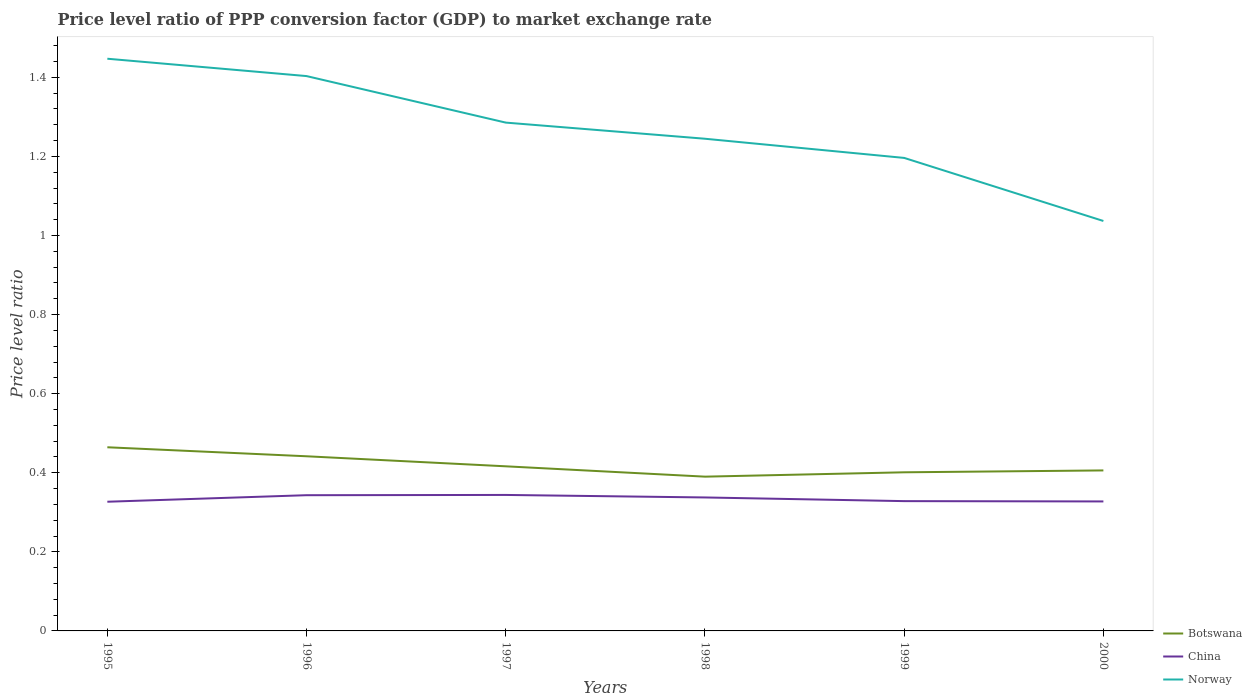How many different coloured lines are there?
Keep it short and to the point. 3. Is the number of lines equal to the number of legend labels?
Provide a succinct answer. Yes. Across all years, what is the maximum price level ratio in China?
Keep it short and to the point. 0.33. What is the total price level ratio in China in the graph?
Provide a short and direct response. 0.01. What is the difference between the highest and the second highest price level ratio in China?
Provide a short and direct response. 0.02. Is the price level ratio in Botswana strictly greater than the price level ratio in China over the years?
Make the answer very short. No. What is the difference between two consecutive major ticks on the Y-axis?
Provide a succinct answer. 0.2. Are the values on the major ticks of Y-axis written in scientific E-notation?
Ensure brevity in your answer.  No. Does the graph contain any zero values?
Your response must be concise. No. Where does the legend appear in the graph?
Offer a very short reply. Bottom right. How are the legend labels stacked?
Your answer should be compact. Vertical. What is the title of the graph?
Offer a very short reply. Price level ratio of PPP conversion factor (GDP) to market exchange rate. What is the label or title of the Y-axis?
Make the answer very short. Price level ratio. What is the Price level ratio of Botswana in 1995?
Offer a very short reply. 0.46. What is the Price level ratio in China in 1995?
Make the answer very short. 0.33. What is the Price level ratio of Norway in 1995?
Provide a succinct answer. 1.45. What is the Price level ratio of Botswana in 1996?
Your response must be concise. 0.44. What is the Price level ratio in China in 1996?
Give a very brief answer. 0.34. What is the Price level ratio in Norway in 1996?
Give a very brief answer. 1.4. What is the Price level ratio of Botswana in 1997?
Provide a short and direct response. 0.42. What is the Price level ratio of China in 1997?
Ensure brevity in your answer.  0.34. What is the Price level ratio of Norway in 1997?
Keep it short and to the point. 1.29. What is the Price level ratio in Botswana in 1998?
Your response must be concise. 0.39. What is the Price level ratio of China in 1998?
Make the answer very short. 0.34. What is the Price level ratio of Norway in 1998?
Your answer should be compact. 1.24. What is the Price level ratio in Botswana in 1999?
Your response must be concise. 0.4. What is the Price level ratio of China in 1999?
Give a very brief answer. 0.33. What is the Price level ratio of Norway in 1999?
Make the answer very short. 1.2. What is the Price level ratio in Botswana in 2000?
Ensure brevity in your answer.  0.41. What is the Price level ratio of China in 2000?
Make the answer very short. 0.33. What is the Price level ratio in Norway in 2000?
Offer a terse response. 1.04. Across all years, what is the maximum Price level ratio of Botswana?
Offer a very short reply. 0.46. Across all years, what is the maximum Price level ratio of China?
Offer a very short reply. 0.34. Across all years, what is the maximum Price level ratio of Norway?
Offer a terse response. 1.45. Across all years, what is the minimum Price level ratio of Botswana?
Provide a short and direct response. 0.39. Across all years, what is the minimum Price level ratio of China?
Provide a succinct answer. 0.33. Across all years, what is the minimum Price level ratio of Norway?
Your response must be concise. 1.04. What is the total Price level ratio of Botswana in the graph?
Keep it short and to the point. 2.52. What is the total Price level ratio of China in the graph?
Make the answer very short. 2.01. What is the total Price level ratio in Norway in the graph?
Ensure brevity in your answer.  7.61. What is the difference between the Price level ratio of Botswana in 1995 and that in 1996?
Offer a terse response. 0.02. What is the difference between the Price level ratio of China in 1995 and that in 1996?
Make the answer very short. -0.02. What is the difference between the Price level ratio of Norway in 1995 and that in 1996?
Provide a short and direct response. 0.04. What is the difference between the Price level ratio in Botswana in 1995 and that in 1997?
Make the answer very short. 0.05. What is the difference between the Price level ratio of China in 1995 and that in 1997?
Offer a terse response. -0.02. What is the difference between the Price level ratio of Norway in 1995 and that in 1997?
Your response must be concise. 0.16. What is the difference between the Price level ratio of Botswana in 1995 and that in 1998?
Give a very brief answer. 0.07. What is the difference between the Price level ratio of China in 1995 and that in 1998?
Your answer should be compact. -0.01. What is the difference between the Price level ratio of Norway in 1995 and that in 1998?
Keep it short and to the point. 0.2. What is the difference between the Price level ratio in Botswana in 1995 and that in 1999?
Provide a short and direct response. 0.06. What is the difference between the Price level ratio of China in 1995 and that in 1999?
Keep it short and to the point. -0. What is the difference between the Price level ratio of Norway in 1995 and that in 1999?
Your answer should be very brief. 0.25. What is the difference between the Price level ratio in Botswana in 1995 and that in 2000?
Give a very brief answer. 0.06. What is the difference between the Price level ratio in China in 1995 and that in 2000?
Ensure brevity in your answer.  -0. What is the difference between the Price level ratio in Norway in 1995 and that in 2000?
Ensure brevity in your answer.  0.41. What is the difference between the Price level ratio of Botswana in 1996 and that in 1997?
Ensure brevity in your answer.  0.03. What is the difference between the Price level ratio in China in 1996 and that in 1997?
Make the answer very short. -0. What is the difference between the Price level ratio in Norway in 1996 and that in 1997?
Your response must be concise. 0.12. What is the difference between the Price level ratio in Botswana in 1996 and that in 1998?
Ensure brevity in your answer.  0.05. What is the difference between the Price level ratio in China in 1996 and that in 1998?
Offer a very short reply. 0.01. What is the difference between the Price level ratio of Norway in 1996 and that in 1998?
Offer a terse response. 0.16. What is the difference between the Price level ratio in Botswana in 1996 and that in 1999?
Offer a terse response. 0.04. What is the difference between the Price level ratio in China in 1996 and that in 1999?
Provide a succinct answer. 0.01. What is the difference between the Price level ratio in Norway in 1996 and that in 1999?
Make the answer very short. 0.21. What is the difference between the Price level ratio in Botswana in 1996 and that in 2000?
Ensure brevity in your answer.  0.04. What is the difference between the Price level ratio in China in 1996 and that in 2000?
Offer a terse response. 0.02. What is the difference between the Price level ratio in Norway in 1996 and that in 2000?
Keep it short and to the point. 0.37. What is the difference between the Price level ratio in Botswana in 1997 and that in 1998?
Give a very brief answer. 0.03. What is the difference between the Price level ratio in China in 1997 and that in 1998?
Your answer should be compact. 0.01. What is the difference between the Price level ratio in Norway in 1997 and that in 1998?
Provide a succinct answer. 0.04. What is the difference between the Price level ratio in Botswana in 1997 and that in 1999?
Your answer should be very brief. 0.02. What is the difference between the Price level ratio of China in 1997 and that in 1999?
Your answer should be very brief. 0.02. What is the difference between the Price level ratio in Norway in 1997 and that in 1999?
Your answer should be compact. 0.09. What is the difference between the Price level ratio in Botswana in 1997 and that in 2000?
Your answer should be very brief. 0.01. What is the difference between the Price level ratio of China in 1997 and that in 2000?
Your answer should be compact. 0.02. What is the difference between the Price level ratio of Norway in 1997 and that in 2000?
Ensure brevity in your answer.  0.25. What is the difference between the Price level ratio in Botswana in 1998 and that in 1999?
Your answer should be very brief. -0.01. What is the difference between the Price level ratio of China in 1998 and that in 1999?
Your response must be concise. 0.01. What is the difference between the Price level ratio of Norway in 1998 and that in 1999?
Offer a very short reply. 0.05. What is the difference between the Price level ratio in Botswana in 1998 and that in 2000?
Make the answer very short. -0.02. What is the difference between the Price level ratio of China in 1998 and that in 2000?
Keep it short and to the point. 0.01. What is the difference between the Price level ratio in Norway in 1998 and that in 2000?
Make the answer very short. 0.21. What is the difference between the Price level ratio in Botswana in 1999 and that in 2000?
Your answer should be compact. -0. What is the difference between the Price level ratio in China in 1999 and that in 2000?
Your answer should be compact. 0. What is the difference between the Price level ratio in Norway in 1999 and that in 2000?
Ensure brevity in your answer.  0.16. What is the difference between the Price level ratio of Botswana in 1995 and the Price level ratio of China in 1996?
Your answer should be very brief. 0.12. What is the difference between the Price level ratio of Botswana in 1995 and the Price level ratio of Norway in 1996?
Your response must be concise. -0.94. What is the difference between the Price level ratio in China in 1995 and the Price level ratio in Norway in 1996?
Your answer should be very brief. -1.08. What is the difference between the Price level ratio of Botswana in 1995 and the Price level ratio of China in 1997?
Keep it short and to the point. 0.12. What is the difference between the Price level ratio of Botswana in 1995 and the Price level ratio of Norway in 1997?
Offer a terse response. -0.82. What is the difference between the Price level ratio in China in 1995 and the Price level ratio in Norway in 1997?
Provide a short and direct response. -0.96. What is the difference between the Price level ratio of Botswana in 1995 and the Price level ratio of China in 1998?
Give a very brief answer. 0.13. What is the difference between the Price level ratio in Botswana in 1995 and the Price level ratio in Norway in 1998?
Your answer should be compact. -0.78. What is the difference between the Price level ratio of China in 1995 and the Price level ratio of Norway in 1998?
Give a very brief answer. -0.92. What is the difference between the Price level ratio in Botswana in 1995 and the Price level ratio in China in 1999?
Make the answer very short. 0.14. What is the difference between the Price level ratio of Botswana in 1995 and the Price level ratio of Norway in 1999?
Provide a short and direct response. -0.73. What is the difference between the Price level ratio of China in 1995 and the Price level ratio of Norway in 1999?
Your answer should be very brief. -0.87. What is the difference between the Price level ratio in Botswana in 1995 and the Price level ratio in China in 2000?
Your response must be concise. 0.14. What is the difference between the Price level ratio in Botswana in 1995 and the Price level ratio in Norway in 2000?
Keep it short and to the point. -0.57. What is the difference between the Price level ratio of China in 1995 and the Price level ratio of Norway in 2000?
Offer a very short reply. -0.71. What is the difference between the Price level ratio of Botswana in 1996 and the Price level ratio of China in 1997?
Your response must be concise. 0.1. What is the difference between the Price level ratio of Botswana in 1996 and the Price level ratio of Norway in 1997?
Your answer should be compact. -0.84. What is the difference between the Price level ratio of China in 1996 and the Price level ratio of Norway in 1997?
Give a very brief answer. -0.94. What is the difference between the Price level ratio of Botswana in 1996 and the Price level ratio of China in 1998?
Your response must be concise. 0.1. What is the difference between the Price level ratio of Botswana in 1996 and the Price level ratio of Norway in 1998?
Provide a short and direct response. -0.8. What is the difference between the Price level ratio in China in 1996 and the Price level ratio in Norway in 1998?
Provide a short and direct response. -0.9. What is the difference between the Price level ratio in Botswana in 1996 and the Price level ratio in China in 1999?
Give a very brief answer. 0.11. What is the difference between the Price level ratio in Botswana in 1996 and the Price level ratio in Norway in 1999?
Keep it short and to the point. -0.75. What is the difference between the Price level ratio of China in 1996 and the Price level ratio of Norway in 1999?
Your answer should be very brief. -0.85. What is the difference between the Price level ratio of Botswana in 1996 and the Price level ratio of China in 2000?
Your response must be concise. 0.11. What is the difference between the Price level ratio of Botswana in 1996 and the Price level ratio of Norway in 2000?
Your answer should be compact. -0.59. What is the difference between the Price level ratio in China in 1996 and the Price level ratio in Norway in 2000?
Your answer should be very brief. -0.69. What is the difference between the Price level ratio of Botswana in 1997 and the Price level ratio of China in 1998?
Offer a very short reply. 0.08. What is the difference between the Price level ratio in Botswana in 1997 and the Price level ratio in Norway in 1998?
Offer a terse response. -0.83. What is the difference between the Price level ratio in China in 1997 and the Price level ratio in Norway in 1998?
Your response must be concise. -0.9. What is the difference between the Price level ratio of Botswana in 1997 and the Price level ratio of China in 1999?
Your answer should be very brief. 0.09. What is the difference between the Price level ratio in Botswana in 1997 and the Price level ratio in Norway in 1999?
Give a very brief answer. -0.78. What is the difference between the Price level ratio in China in 1997 and the Price level ratio in Norway in 1999?
Keep it short and to the point. -0.85. What is the difference between the Price level ratio of Botswana in 1997 and the Price level ratio of China in 2000?
Provide a short and direct response. 0.09. What is the difference between the Price level ratio in Botswana in 1997 and the Price level ratio in Norway in 2000?
Your answer should be very brief. -0.62. What is the difference between the Price level ratio in China in 1997 and the Price level ratio in Norway in 2000?
Your answer should be compact. -0.69. What is the difference between the Price level ratio in Botswana in 1998 and the Price level ratio in China in 1999?
Your answer should be very brief. 0.06. What is the difference between the Price level ratio of Botswana in 1998 and the Price level ratio of Norway in 1999?
Give a very brief answer. -0.81. What is the difference between the Price level ratio of China in 1998 and the Price level ratio of Norway in 1999?
Your answer should be very brief. -0.86. What is the difference between the Price level ratio of Botswana in 1998 and the Price level ratio of China in 2000?
Give a very brief answer. 0.06. What is the difference between the Price level ratio of Botswana in 1998 and the Price level ratio of Norway in 2000?
Offer a terse response. -0.65. What is the difference between the Price level ratio of China in 1998 and the Price level ratio of Norway in 2000?
Provide a short and direct response. -0.7. What is the difference between the Price level ratio in Botswana in 1999 and the Price level ratio in China in 2000?
Provide a short and direct response. 0.07. What is the difference between the Price level ratio of Botswana in 1999 and the Price level ratio of Norway in 2000?
Keep it short and to the point. -0.64. What is the difference between the Price level ratio of China in 1999 and the Price level ratio of Norway in 2000?
Make the answer very short. -0.71. What is the average Price level ratio of Botswana per year?
Make the answer very short. 0.42. What is the average Price level ratio in China per year?
Your response must be concise. 0.33. What is the average Price level ratio in Norway per year?
Offer a very short reply. 1.27. In the year 1995, what is the difference between the Price level ratio of Botswana and Price level ratio of China?
Offer a terse response. 0.14. In the year 1995, what is the difference between the Price level ratio of Botswana and Price level ratio of Norway?
Offer a very short reply. -0.98. In the year 1995, what is the difference between the Price level ratio of China and Price level ratio of Norway?
Offer a very short reply. -1.12. In the year 1996, what is the difference between the Price level ratio in Botswana and Price level ratio in China?
Keep it short and to the point. 0.1. In the year 1996, what is the difference between the Price level ratio of Botswana and Price level ratio of Norway?
Your answer should be compact. -0.96. In the year 1996, what is the difference between the Price level ratio of China and Price level ratio of Norway?
Keep it short and to the point. -1.06. In the year 1997, what is the difference between the Price level ratio of Botswana and Price level ratio of China?
Ensure brevity in your answer.  0.07. In the year 1997, what is the difference between the Price level ratio in Botswana and Price level ratio in Norway?
Make the answer very short. -0.87. In the year 1997, what is the difference between the Price level ratio of China and Price level ratio of Norway?
Make the answer very short. -0.94. In the year 1998, what is the difference between the Price level ratio of Botswana and Price level ratio of China?
Your answer should be compact. 0.05. In the year 1998, what is the difference between the Price level ratio in Botswana and Price level ratio in Norway?
Ensure brevity in your answer.  -0.85. In the year 1998, what is the difference between the Price level ratio in China and Price level ratio in Norway?
Your answer should be very brief. -0.91. In the year 1999, what is the difference between the Price level ratio in Botswana and Price level ratio in China?
Your answer should be compact. 0.07. In the year 1999, what is the difference between the Price level ratio in Botswana and Price level ratio in Norway?
Keep it short and to the point. -0.8. In the year 1999, what is the difference between the Price level ratio of China and Price level ratio of Norway?
Ensure brevity in your answer.  -0.87. In the year 2000, what is the difference between the Price level ratio of Botswana and Price level ratio of China?
Provide a succinct answer. 0.08. In the year 2000, what is the difference between the Price level ratio in Botswana and Price level ratio in Norway?
Give a very brief answer. -0.63. In the year 2000, what is the difference between the Price level ratio of China and Price level ratio of Norway?
Offer a very short reply. -0.71. What is the ratio of the Price level ratio in Botswana in 1995 to that in 1996?
Your answer should be very brief. 1.05. What is the ratio of the Price level ratio in China in 1995 to that in 1996?
Ensure brevity in your answer.  0.95. What is the ratio of the Price level ratio of Norway in 1995 to that in 1996?
Offer a very short reply. 1.03. What is the ratio of the Price level ratio of Botswana in 1995 to that in 1997?
Give a very brief answer. 1.12. What is the ratio of the Price level ratio of China in 1995 to that in 1997?
Your answer should be very brief. 0.95. What is the ratio of the Price level ratio of Norway in 1995 to that in 1997?
Your response must be concise. 1.13. What is the ratio of the Price level ratio in Botswana in 1995 to that in 1998?
Your answer should be very brief. 1.19. What is the ratio of the Price level ratio in China in 1995 to that in 1998?
Your answer should be very brief. 0.97. What is the ratio of the Price level ratio of Norway in 1995 to that in 1998?
Offer a terse response. 1.16. What is the ratio of the Price level ratio of Botswana in 1995 to that in 1999?
Offer a very short reply. 1.16. What is the ratio of the Price level ratio in China in 1995 to that in 1999?
Provide a short and direct response. 1. What is the ratio of the Price level ratio of Norway in 1995 to that in 1999?
Give a very brief answer. 1.21. What is the ratio of the Price level ratio in Botswana in 1995 to that in 2000?
Your response must be concise. 1.14. What is the ratio of the Price level ratio in China in 1995 to that in 2000?
Provide a succinct answer. 1. What is the ratio of the Price level ratio of Norway in 1995 to that in 2000?
Provide a short and direct response. 1.4. What is the ratio of the Price level ratio of Botswana in 1996 to that in 1997?
Give a very brief answer. 1.06. What is the ratio of the Price level ratio of Norway in 1996 to that in 1997?
Give a very brief answer. 1.09. What is the ratio of the Price level ratio of Botswana in 1996 to that in 1998?
Your response must be concise. 1.13. What is the ratio of the Price level ratio of China in 1996 to that in 1998?
Offer a terse response. 1.02. What is the ratio of the Price level ratio in Norway in 1996 to that in 1998?
Provide a succinct answer. 1.13. What is the ratio of the Price level ratio of Botswana in 1996 to that in 1999?
Your answer should be very brief. 1.1. What is the ratio of the Price level ratio in China in 1996 to that in 1999?
Offer a very short reply. 1.05. What is the ratio of the Price level ratio of Norway in 1996 to that in 1999?
Ensure brevity in your answer.  1.17. What is the ratio of the Price level ratio of Botswana in 1996 to that in 2000?
Your response must be concise. 1.09. What is the ratio of the Price level ratio of China in 1996 to that in 2000?
Keep it short and to the point. 1.05. What is the ratio of the Price level ratio in Norway in 1996 to that in 2000?
Your response must be concise. 1.35. What is the ratio of the Price level ratio of Botswana in 1997 to that in 1998?
Your answer should be compact. 1.07. What is the ratio of the Price level ratio of China in 1997 to that in 1998?
Your answer should be compact. 1.02. What is the ratio of the Price level ratio in Norway in 1997 to that in 1998?
Keep it short and to the point. 1.03. What is the ratio of the Price level ratio in Botswana in 1997 to that in 1999?
Your answer should be very brief. 1.04. What is the ratio of the Price level ratio of China in 1997 to that in 1999?
Make the answer very short. 1.05. What is the ratio of the Price level ratio in Norway in 1997 to that in 1999?
Offer a very short reply. 1.07. What is the ratio of the Price level ratio of Botswana in 1997 to that in 2000?
Give a very brief answer. 1.03. What is the ratio of the Price level ratio of China in 1997 to that in 2000?
Keep it short and to the point. 1.05. What is the ratio of the Price level ratio of Norway in 1997 to that in 2000?
Your answer should be very brief. 1.24. What is the ratio of the Price level ratio of Botswana in 1998 to that in 1999?
Provide a succinct answer. 0.97. What is the ratio of the Price level ratio of China in 1998 to that in 1999?
Keep it short and to the point. 1.03. What is the ratio of the Price level ratio in Norway in 1998 to that in 1999?
Your answer should be compact. 1.04. What is the ratio of the Price level ratio in Botswana in 1998 to that in 2000?
Your answer should be compact. 0.96. What is the ratio of the Price level ratio of China in 1998 to that in 2000?
Provide a short and direct response. 1.03. What is the ratio of the Price level ratio of Norway in 1998 to that in 2000?
Provide a short and direct response. 1.2. What is the ratio of the Price level ratio of Botswana in 1999 to that in 2000?
Your answer should be very brief. 0.99. What is the ratio of the Price level ratio of Norway in 1999 to that in 2000?
Ensure brevity in your answer.  1.15. What is the difference between the highest and the second highest Price level ratio in Botswana?
Ensure brevity in your answer.  0.02. What is the difference between the highest and the second highest Price level ratio in China?
Your answer should be compact. 0. What is the difference between the highest and the second highest Price level ratio in Norway?
Your answer should be compact. 0.04. What is the difference between the highest and the lowest Price level ratio in Botswana?
Keep it short and to the point. 0.07. What is the difference between the highest and the lowest Price level ratio of China?
Ensure brevity in your answer.  0.02. What is the difference between the highest and the lowest Price level ratio of Norway?
Give a very brief answer. 0.41. 